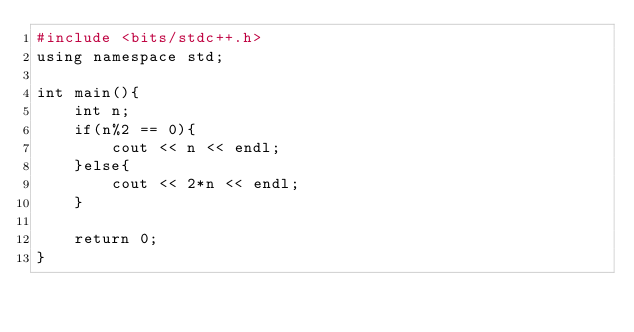<code> <loc_0><loc_0><loc_500><loc_500><_Awk_>#include <bits/stdc++.h>
using namespace std;

int main(){
    int n;
    if(n%2 == 0){
        cout << n << endl;
    }else{
        cout << 2*n << endl;
    }

    return 0;
}
</code> 